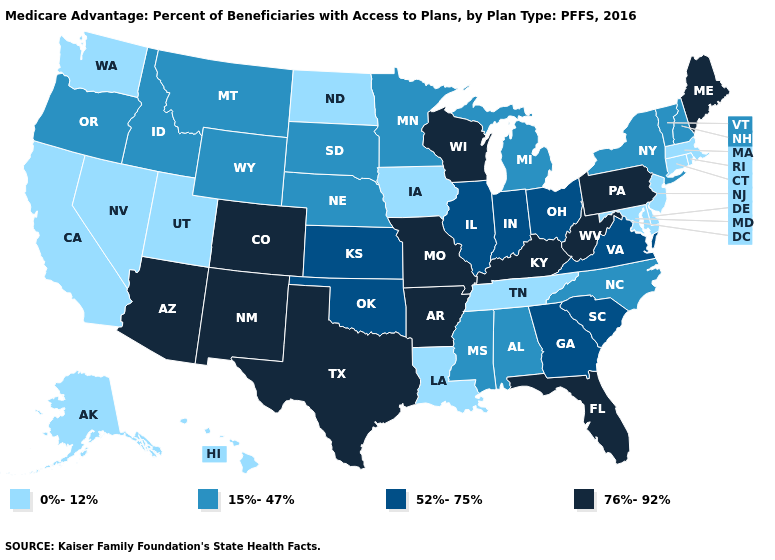What is the value of North Carolina?
Write a very short answer. 15%-47%. Name the states that have a value in the range 52%-75%?
Quick response, please. Georgia, Illinois, Indiana, Kansas, Ohio, Oklahoma, South Carolina, Virginia. Does Nebraska have the same value as Georgia?
Answer briefly. No. Name the states that have a value in the range 76%-92%?
Be succinct. Colorado, Florida, Kentucky, Maine, Missouri, New Mexico, Pennsylvania, Texas, Wisconsin, West Virginia, Arkansas, Arizona. Among the states that border Kansas , does Colorado have the lowest value?
Give a very brief answer. No. Name the states that have a value in the range 0%-12%?
Be succinct. California, Connecticut, Delaware, Hawaii, Iowa, Louisiana, Massachusetts, Maryland, North Dakota, New Jersey, Nevada, Rhode Island, Alaska, Tennessee, Utah, Washington. Name the states that have a value in the range 15%-47%?
Give a very brief answer. Idaho, Michigan, Minnesota, Mississippi, Montana, North Carolina, Nebraska, New Hampshire, New York, Oregon, South Dakota, Vermont, Wyoming, Alabama. Name the states that have a value in the range 52%-75%?
Write a very short answer. Georgia, Illinois, Indiana, Kansas, Ohio, Oklahoma, South Carolina, Virginia. Which states have the highest value in the USA?
Short answer required. Colorado, Florida, Kentucky, Maine, Missouri, New Mexico, Pennsylvania, Texas, Wisconsin, West Virginia, Arkansas, Arizona. What is the value of Arkansas?
Concise answer only. 76%-92%. Does the first symbol in the legend represent the smallest category?
Keep it brief. Yes. What is the highest value in the USA?
Concise answer only. 76%-92%. Does Washington have a lower value than Delaware?
Answer briefly. No. Does Wisconsin have the highest value in the MidWest?
Give a very brief answer. Yes. Among the states that border New Jersey , which have the highest value?
Short answer required. Pennsylvania. 